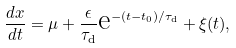<formula> <loc_0><loc_0><loc_500><loc_500>\frac { d x } { d t } = \mu + \frac { \epsilon } { \tau _ { \text {d} } } \text {e} ^ { - ( t - t _ { 0 } ) / \tau _ { \text {d} } } + \xi ( t ) ,</formula> 